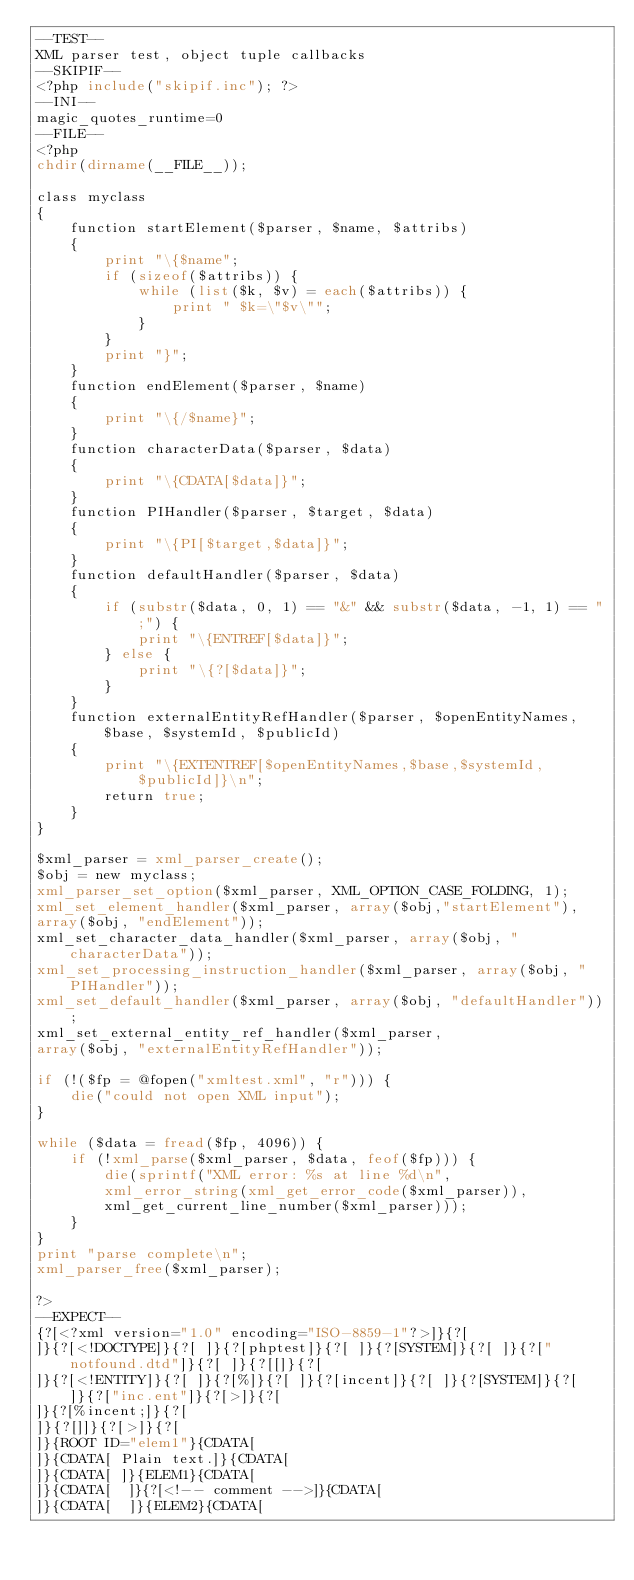<code> <loc_0><loc_0><loc_500><loc_500><_PHP_>--TEST--
XML parser test, object tuple callbacks
--SKIPIF--
<?php include("skipif.inc"); ?>
--INI--
magic_quotes_runtime=0
--FILE--
<?php
chdir(dirname(__FILE__));

class myclass
{
	function startElement($parser, $name, $attribs)
	{
		print "\{$name";
		if (sizeof($attribs)) {
			while (list($k, $v) = each($attribs)) {
				print " $k=\"$v\"";
			}
		}
		print "}";
	}
	function endElement($parser, $name)
	{
		print "\{/$name}";
	}
	function characterData($parser, $data)
	{
		print "\{CDATA[$data]}";
	}
	function PIHandler($parser, $target, $data)
	{
		print "\{PI[$target,$data]}";
	}
	function defaultHandler($parser, $data)
	{
		if (substr($data, 0, 1) == "&" && substr($data, -1, 1) == ";") {
			print "\{ENTREF[$data]}";
		} else {
			print "\{?[$data]}";
		}
	}
	function externalEntityRefHandler($parser, $openEntityNames, $base,	$systemId, $publicId)
	{
		print "\{EXTENTREF[$openEntityNames,$base,$systemId,$publicId]}\n";
		return true;
	}
}

$xml_parser = xml_parser_create();
$obj = new myclass;
xml_parser_set_option($xml_parser, XML_OPTION_CASE_FOLDING, 1);
xml_set_element_handler($xml_parser, array($obj,"startElement"),
array($obj, "endElement"));
xml_set_character_data_handler($xml_parser, array($obj, "characterData"));
xml_set_processing_instruction_handler($xml_parser, array($obj, "PIHandler"));
xml_set_default_handler($xml_parser, array($obj, "defaultHandler"));
xml_set_external_entity_ref_handler($xml_parser,
array($obj, "externalEntityRefHandler"));

if (!($fp = @fopen("xmltest.xml", "r"))) {
	die("could not open XML input");
}

while ($data = fread($fp, 4096)) {
	if (!xml_parse($xml_parser, $data, feof($fp))) {
		die(sprintf("XML error: %s at line %d\n",
		xml_error_string(xml_get_error_code($xml_parser)),
		xml_get_current_line_number($xml_parser)));
	}
}
print "parse complete\n";
xml_parser_free($xml_parser);

?>
--EXPECT--
{?[<?xml version="1.0" encoding="ISO-8859-1"?>]}{?[
]}{?[<!DOCTYPE]}{?[ ]}{?[phptest]}{?[ ]}{?[SYSTEM]}{?[ ]}{?["notfound.dtd"]}{?[ ]}{?[[]}{?[
]}{?[<!ENTITY]}{?[ ]}{?[%]}{?[ ]}{?[incent]}{?[ ]}{?[SYSTEM]}{?[ ]}{?["inc.ent"]}{?[>]}{?[
]}{?[%incent;]}{?[
]}{?[]]}{?[>]}{?[
]}{ROOT ID="elem1"}{CDATA[
]}{CDATA[ Plain text.]}{CDATA[
]}{CDATA[ ]}{ELEM1}{CDATA[
]}{CDATA[  ]}{?[<!-- comment -->]}{CDATA[
]}{CDATA[  ]}{ELEM2}{CDATA[</code> 